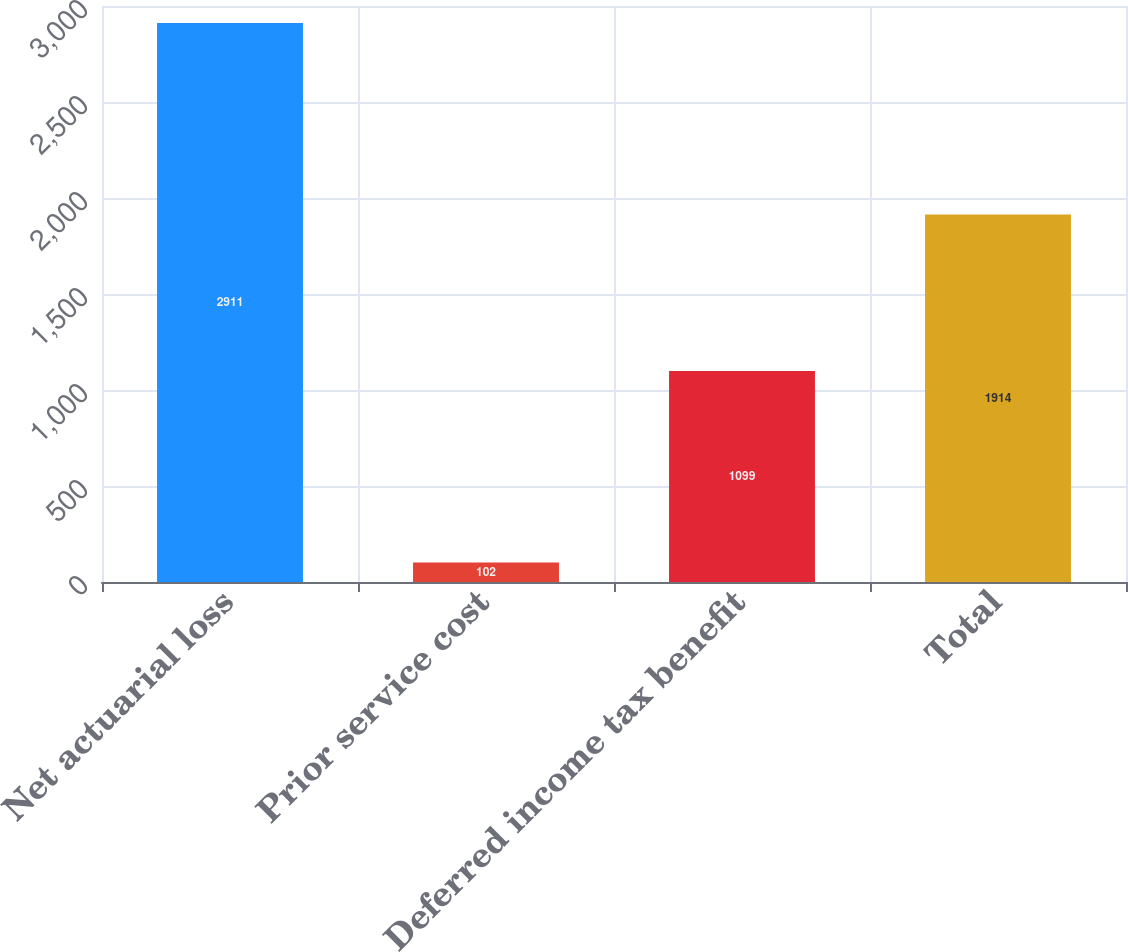<chart> <loc_0><loc_0><loc_500><loc_500><bar_chart><fcel>Net actuarial loss<fcel>Prior service cost<fcel>Deferred income tax benefit<fcel>Total<nl><fcel>2911<fcel>102<fcel>1099<fcel>1914<nl></chart> 